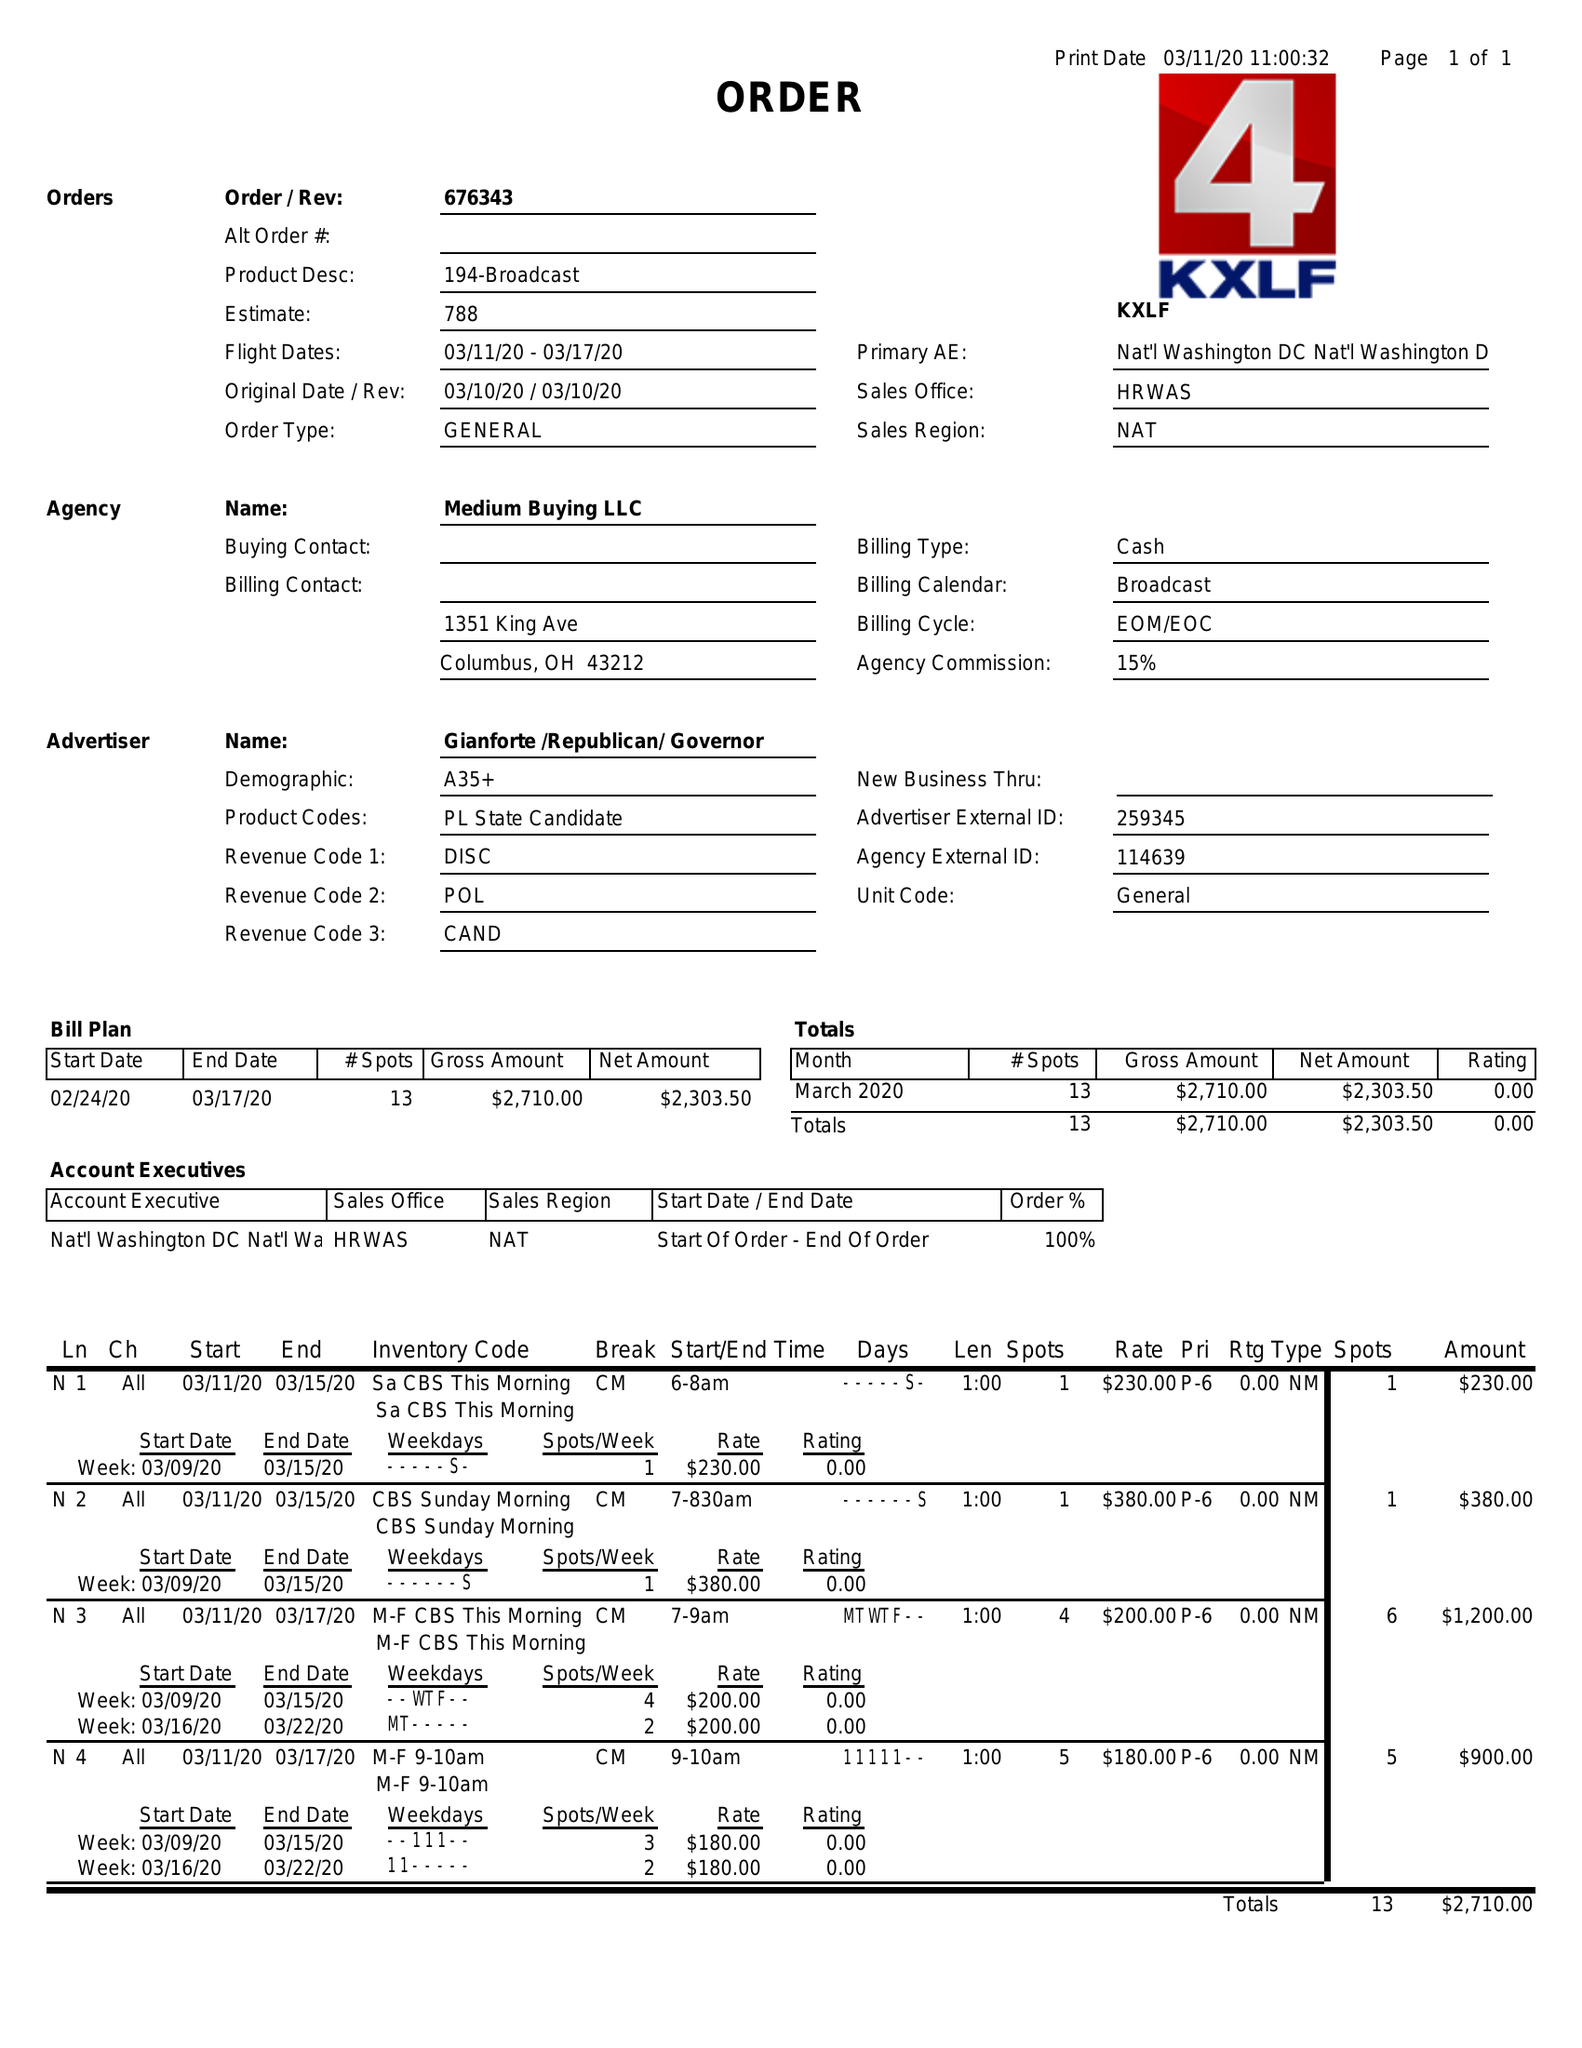What is the value for the contract_num?
Answer the question using a single word or phrase. 676343 